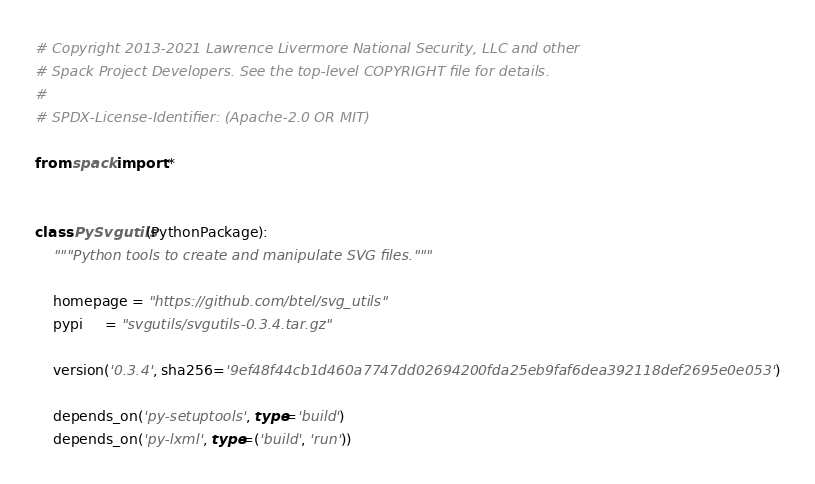Convert code to text. <code><loc_0><loc_0><loc_500><loc_500><_Python_># Copyright 2013-2021 Lawrence Livermore National Security, LLC and other
# Spack Project Developers. See the top-level COPYRIGHT file for details.
#
# SPDX-License-Identifier: (Apache-2.0 OR MIT)

from spack import *


class PySvgutils(PythonPackage):
    """Python tools to create and manipulate SVG files."""

    homepage = "https://github.com/btel/svg_utils"
    pypi     = "svgutils/svgutils-0.3.4.tar.gz"

    version('0.3.4', sha256='9ef48f44cb1d460a7747dd02694200fda25eb9faf6dea392118def2695e0e053')

    depends_on('py-setuptools', type='build')
    depends_on('py-lxml', type=('build', 'run'))
</code> 